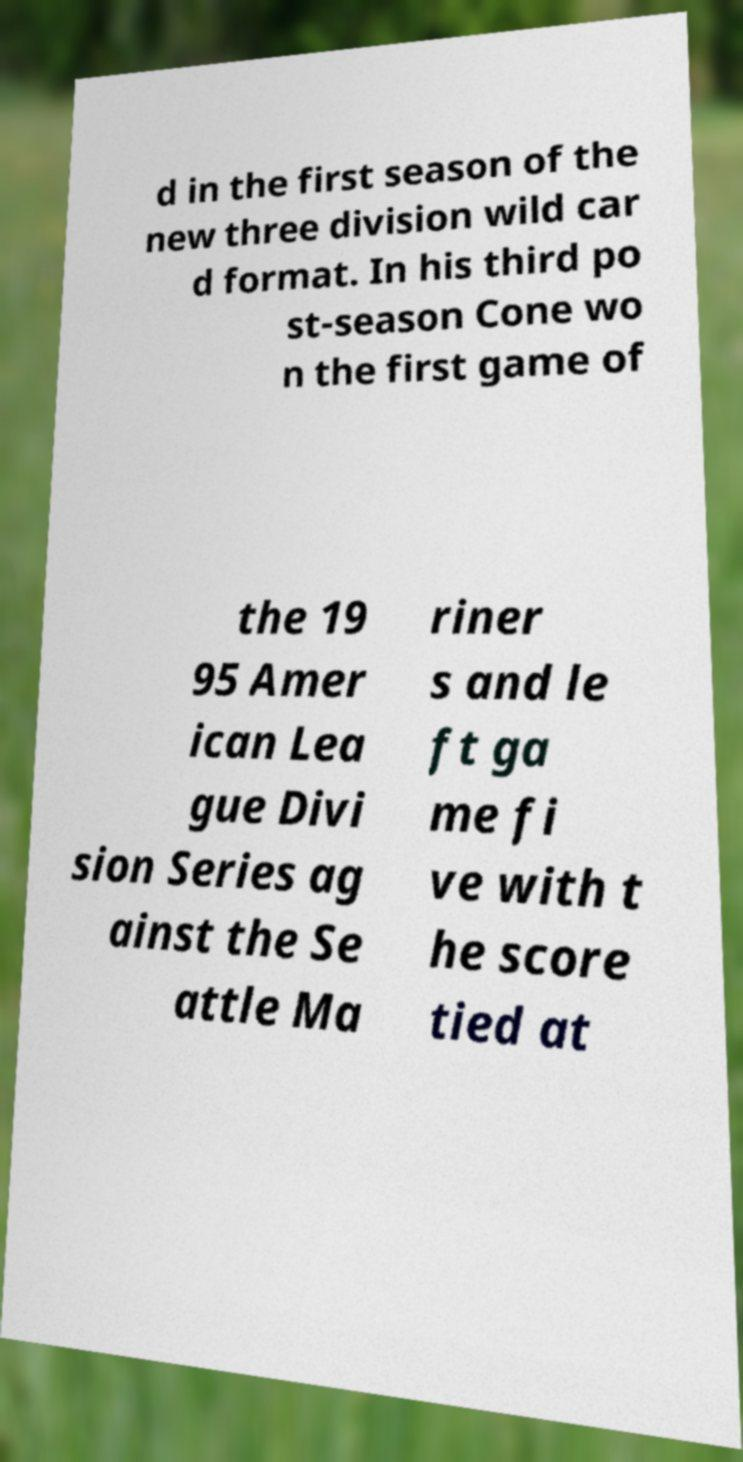Could you assist in decoding the text presented in this image and type it out clearly? d in the first season of the new three division wild car d format. In his third po st-season Cone wo n the first game of the 19 95 Amer ican Lea gue Divi sion Series ag ainst the Se attle Ma riner s and le ft ga me fi ve with t he score tied at 